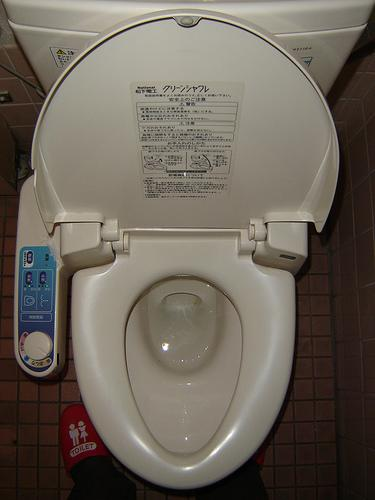Enumerate the distinct features of the toilet that can be found in the image. Dial, button, control panel, seat, bowl, tank, hinges, and lid are the distinct features of the toilet. How would you rate the overall quality of this image? Moderate quality, as it provides clear details of the objects and their positions. Summarize the image in one sentence. An image of a toilet with various control options, stickers, and a red slipper on the floor. What kind of footwear is on the floor and what color is it? Red slipper on the floor. Analyze the interaction between the red slipper and other objects in the image. The red slipper is just lying on the floor near the toilet, without direct interaction with other objects. How many small brown grout lines are there in the image? There are 9 small brown grout lines. Determine the sentiment portrayed by the image. Neutral sentiment, as it displays a typical bathroom scene. Do you see the purple dial on the wall of the toilet? The dial is mentioned to be on the arm of the toilet, but the instruction is asking for a purple dial on the wall, which is not correct. Identify the dual sign found in the image. Male and female on the cup. Is there a black tile on the ceiling? The brown floor is mentioned to have black tiles, but the instruction is asking for a black tile on the ceiling which is misleading. Create a detailed description of the entire scene based on the given image. A bathroom with a white toilet, brown tile flooring, and various features on the toilet arm. There is a red cup on the floor, a person wearing red and white slippers, and several stickers and warning labels. Is the toilet lid open or closed? What is on the toilet lid? Open with a white sticker with black text. What is the color of the cup on the floor near the toilet? Red. Is there any orange sticker with white text on the toliet lid? The sticker is described as white with black text, but the instruction is asking for an orange sticker with white text which is incorrect. Can you find a silver button on the right side of the toilet? The button is mentioned as being on the arm of the toilet, but the instruction is asking for a silver button on the right side, which is misleading. What type of footwear is lying on the floor in front of the toilet? Red and white slipper. What is the activity happening around the toilet involving the person standing? Person standing in front of the toilet, wearing red and white slippers. State the type of flooring in the image. Brown floor with black tiles and brown grout lines. In the image, identify the main components of the toilet. Bowl, seat, lid, tank, and control panel. Which features can be found on the arm of the toilet? List them. Dial, button, and control panel. State the position of the red cup in the image. On the floor near the toilet. What kind of sign is present on the cup? Describe it. Male and female sign. Is there any water in the toilet? Where is it located? Yes, water is present in the toilet bowl. Can you please describe the appearance of the shoes? Red and white slippers. What type of flooring surrounds the toilet? Brown flooring with black tiles and brown grout lines. Can you notice a green slipper on the floor? The slipper is described as red and white, but the instruction is asking for a green slipper which is not accurate. Please describe the positioning of the white sticker in the scene. On the toilet lid. What color and design are the slippers in the image? Red and white. What color are the tiles on the floor and walls in the image? Brown on the floor and white on the wall. What type of information can be found on the back of the toilet? Please explain. Instructions sticker and warning label. List the main components of the white toilet. Lid, seat, bowl, hinges, and tank. Can you see the blue cup on the floor? The cup is mentioned as red, but the instruction is asking for a blue cup which is misleading. Where do the control settings for the toilet appear in the image? On the arm of the toilet. 